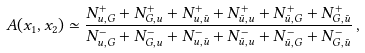Convert formula to latex. <formula><loc_0><loc_0><loc_500><loc_500>A ( x _ { 1 } , x _ { 2 } ) \simeq \frac { N ^ { + } _ { u , G } + N ^ { + } _ { G , u } + N ^ { + } _ { u , \bar { u } } + N ^ { + } _ { \bar { u } , u } + N ^ { + } _ { \bar { u } , G } + N ^ { + } _ { G , \bar { u } } } { N ^ { - } _ { u , G } + N ^ { - } _ { G , u } + N ^ { - } _ { u , \bar { u } } + N ^ { - } _ { \bar { u } , u } + N ^ { - } _ { \bar { u } , G } + N ^ { - } _ { G , \bar { u } } } \, ,</formula> 